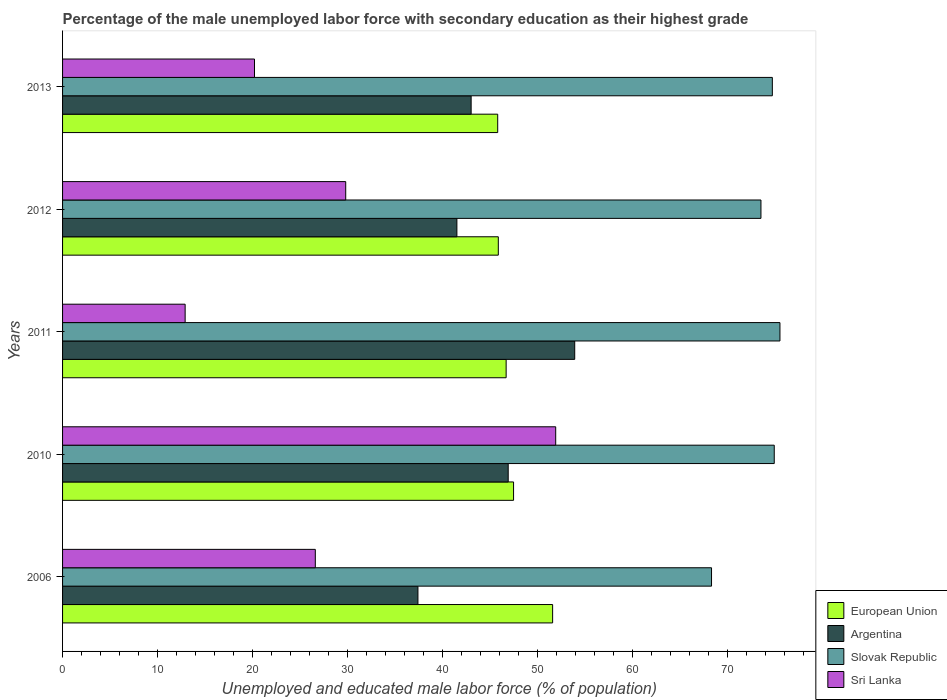How many groups of bars are there?
Your answer should be compact. 5. How many bars are there on the 2nd tick from the top?
Your response must be concise. 4. What is the percentage of the unemployed male labor force with secondary education in Sri Lanka in 2010?
Provide a succinct answer. 51.9. Across all years, what is the maximum percentage of the unemployed male labor force with secondary education in Sri Lanka?
Provide a succinct answer. 51.9. Across all years, what is the minimum percentage of the unemployed male labor force with secondary education in Sri Lanka?
Your answer should be very brief. 12.9. In which year was the percentage of the unemployed male labor force with secondary education in Sri Lanka maximum?
Offer a terse response. 2010. In which year was the percentage of the unemployed male labor force with secondary education in European Union minimum?
Your answer should be compact. 2013. What is the total percentage of the unemployed male labor force with secondary education in Sri Lanka in the graph?
Keep it short and to the point. 141.4. What is the difference between the percentage of the unemployed male labor force with secondary education in Sri Lanka in 2010 and that in 2012?
Provide a short and direct response. 22.1. What is the difference between the percentage of the unemployed male labor force with secondary education in Sri Lanka in 2010 and the percentage of the unemployed male labor force with secondary education in Argentina in 2013?
Your answer should be compact. 8.9. What is the average percentage of the unemployed male labor force with secondary education in Slovak Republic per year?
Make the answer very short. 73.38. In the year 2011, what is the difference between the percentage of the unemployed male labor force with secondary education in Argentina and percentage of the unemployed male labor force with secondary education in Sri Lanka?
Give a very brief answer. 41. What is the ratio of the percentage of the unemployed male labor force with secondary education in Argentina in 2006 to that in 2012?
Your answer should be very brief. 0.9. What is the difference between the highest and the second highest percentage of the unemployed male labor force with secondary education in European Union?
Make the answer very short. 4.11. Is the sum of the percentage of the unemployed male labor force with secondary education in Sri Lanka in 2006 and 2011 greater than the maximum percentage of the unemployed male labor force with secondary education in Slovak Republic across all years?
Provide a short and direct response. No. Is it the case that in every year, the sum of the percentage of the unemployed male labor force with secondary education in European Union and percentage of the unemployed male labor force with secondary education in Sri Lanka is greater than the sum of percentage of the unemployed male labor force with secondary education in Argentina and percentage of the unemployed male labor force with secondary education in Slovak Republic?
Your answer should be very brief. Yes. What does the 4th bar from the top in 2006 represents?
Provide a short and direct response. European Union. What does the 2nd bar from the bottom in 2013 represents?
Make the answer very short. Argentina. Is it the case that in every year, the sum of the percentage of the unemployed male labor force with secondary education in European Union and percentage of the unemployed male labor force with secondary education in Slovak Republic is greater than the percentage of the unemployed male labor force with secondary education in Sri Lanka?
Make the answer very short. Yes. How many bars are there?
Give a very brief answer. 20. Are all the bars in the graph horizontal?
Your answer should be compact. Yes. What is the difference between two consecutive major ticks on the X-axis?
Offer a very short reply. 10. Are the values on the major ticks of X-axis written in scientific E-notation?
Your answer should be compact. No. Does the graph contain any zero values?
Give a very brief answer. No. Where does the legend appear in the graph?
Your response must be concise. Bottom right. How many legend labels are there?
Provide a succinct answer. 4. What is the title of the graph?
Make the answer very short. Percentage of the male unemployed labor force with secondary education as their highest grade. What is the label or title of the X-axis?
Your answer should be compact. Unemployed and educated male labor force (% of population). What is the label or title of the Y-axis?
Make the answer very short. Years. What is the Unemployed and educated male labor force (% of population) in European Union in 2006?
Offer a terse response. 51.58. What is the Unemployed and educated male labor force (% of population) of Argentina in 2006?
Provide a succinct answer. 37.4. What is the Unemployed and educated male labor force (% of population) of Slovak Republic in 2006?
Provide a short and direct response. 68.3. What is the Unemployed and educated male labor force (% of population) of Sri Lanka in 2006?
Give a very brief answer. 26.6. What is the Unemployed and educated male labor force (% of population) in European Union in 2010?
Give a very brief answer. 47.47. What is the Unemployed and educated male labor force (% of population) of Argentina in 2010?
Provide a short and direct response. 46.9. What is the Unemployed and educated male labor force (% of population) in Slovak Republic in 2010?
Give a very brief answer. 74.9. What is the Unemployed and educated male labor force (% of population) in Sri Lanka in 2010?
Give a very brief answer. 51.9. What is the Unemployed and educated male labor force (% of population) of European Union in 2011?
Your answer should be very brief. 46.68. What is the Unemployed and educated male labor force (% of population) of Argentina in 2011?
Provide a short and direct response. 53.9. What is the Unemployed and educated male labor force (% of population) in Slovak Republic in 2011?
Give a very brief answer. 75.5. What is the Unemployed and educated male labor force (% of population) in Sri Lanka in 2011?
Provide a short and direct response. 12.9. What is the Unemployed and educated male labor force (% of population) of European Union in 2012?
Provide a short and direct response. 45.86. What is the Unemployed and educated male labor force (% of population) of Argentina in 2012?
Make the answer very short. 41.5. What is the Unemployed and educated male labor force (% of population) in Slovak Republic in 2012?
Offer a terse response. 73.5. What is the Unemployed and educated male labor force (% of population) of Sri Lanka in 2012?
Ensure brevity in your answer.  29.8. What is the Unemployed and educated male labor force (% of population) in European Union in 2013?
Offer a terse response. 45.79. What is the Unemployed and educated male labor force (% of population) in Slovak Republic in 2013?
Your answer should be compact. 74.7. What is the Unemployed and educated male labor force (% of population) in Sri Lanka in 2013?
Offer a very short reply. 20.2. Across all years, what is the maximum Unemployed and educated male labor force (% of population) in European Union?
Offer a very short reply. 51.58. Across all years, what is the maximum Unemployed and educated male labor force (% of population) in Argentina?
Make the answer very short. 53.9. Across all years, what is the maximum Unemployed and educated male labor force (% of population) of Slovak Republic?
Give a very brief answer. 75.5. Across all years, what is the maximum Unemployed and educated male labor force (% of population) in Sri Lanka?
Give a very brief answer. 51.9. Across all years, what is the minimum Unemployed and educated male labor force (% of population) of European Union?
Offer a very short reply. 45.79. Across all years, what is the minimum Unemployed and educated male labor force (% of population) in Argentina?
Give a very brief answer. 37.4. Across all years, what is the minimum Unemployed and educated male labor force (% of population) in Slovak Republic?
Offer a terse response. 68.3. Across all years, what is the minimum Unemployed and educated male labor force (% of population) of Sri Lanka?
Your answer should be very brief. 12.9. What is the total Unemployed and educated male labor force (% of population) in European Union in the graph?
Keep it short and to the point. 237.38. What is the total Unemployed and educated male labor force (% of population) of Argentina in the graph?
Keep it short and to the point. 222.7. What is the total Unemployed and educated male labor force (% of population) in Slovak Republic in the graph?
Provide a short and direct response. 366.9. What is the total Unemployed and educated male labor force (% of population) in Sri Lanka in the graph?
Keep it short and to the point. 141.4. What is the difference between the Unemployed and educated male labor force (% of population) in European Union in 2006 and that in 2010?
Offer a terse response. 4.11. What is the difference between the Unemployed and educated male labor force (% of population) in Sri Lanka in 2006 and that in 2010?
Your response must be concise. -25.3. What is the difference between the Unemployed and educated male labor force (% of population) in European Union in 2006 and that in 2011?
Provide a succinct answer. 4.89. What is the difference between the Unemployed and educated male labor force (% of population) in Argentina in 2006 and that in 2011?
Offer a very short reply. -16.5. What is the difference between the Unemployed and educated male labor force (% of population) in Slovak Republic in 2006 and that in 2011?
Your response must be concise. -7.2. What is the difference between the Unemployed and educated male labor force (% of population) of European Union in 2006 and that in 2012?
Offer a terse response. 5.72. What is the difference between the Unemployed and educated male labor force (% of population) of Argentina in 2006 and that in 2012?
Offer a very short reply. -4.1. What is the difference between the Unemployed and educated male labor force (% of population) of Slovak Republic in 2006 and that in 2012?
Your answer should be compact. -5.2. What is the difference between the Unemployed and educated male labor force (% of population) of European Union in 2006 and that in 2013?
Your answer should be very brief. 5.78. What is the difference between the Unemployed and educated male labor force (% of population) of European Union in 2010 and that in 2011?
Offer a very short reply. 0.78. What is the difference between the Unemployed and educated male labor force (% of population) of Slovak Republic in 2010 and that in 2011?
Provide a short and direct response. -0.6. What is the difference between the Unemployed and educated male labor force (% of population) of European Union in 2010 and that in 2012?
Offer a very short reply. 1.61. What is the difference between the Unemployed and educated male labor force (% of population) of Argentina in 2010 and that in 2012?
Provide a short and direct response. 5.4. What is the difference between the Unemployed and educated male labor force (% of population) of Slovak Republic in 2010 and that in 2012?
Offer a terse response. 1.4. What is the difference between the Unemployed and educated male labor force (% of population) of Sri Lanka in 2010 and that in 2012?
Provide a short and direct response. 22.1. What is the difference between the Unemployed and educated male labor force (% of population) in European Union in 2010 and that in 2013?
Make the answer very short. 1.67. What is the difference between the Unemployed and educated male labor force (% of population) of Argentina in 2010 and that in 2013?
Make the answer very short. 3.9. What is the difference between the Unemployed and educated male labor force (% of population) of Sri Lanka in 2010 and that in 2013?
Provide a short and direct response. 31.7. What is the difference between the Unemployed and educated male labor force (% of population) in European Union in 2011 and that in 2012?
Your answer should be very brief. 0.82. What is the difference between the Unemployed and educated male labor force (% of population) in Sri Lanka in 2011 and that in 2012?
Your answer should be compact. -16.9. What is the difference between the Unemployed and educated male labor force (% of population) in European Union in 2011 and that in 2013?
Your answer should be compact. 0.89. What is the difference between the Unemployed and educated male labor force (% of population) in Argentina in 2011 and that in 2013?
Give a very brief answer. 10.9. What is the difference between the Unemployed and educated male labor force (% of population) of Sri Lanka in 2011 and that in 2013?
Keep it short and to the point. -7.3. What is the difference between the Unemployed and educated male labor force (% of population) in European Union in 2012 and that in 2013?
Your response must be concise. 0.06. What is the difference between the Unemployed and educated male labor force (% of population) of Slovak Republic in 2012 and that in 2013?
Give a very brief answer. -1.2. What is the difference between the Unemployed and educated male labor force (% of population) in European Union in 2006 and the Unemployed and educated male labor force (% of population) in Argentina in 2010?
Provide a short and direct response. 4.68. What is the difference between the Unemployed and educated male labor force (% of population) in European Union in 2006 and the Unemployed and educated male labor force (% of population) in Slovak Republic in 2010?
Give a very brief answer. -23.32. What is the difference between the Unemployed and educated male labor force (% of population) in European Union in 2006 and the Unemployed and educated male labor force (% of population) in Sri Lanka in 2010?
Ensure brevity in your answer.  -0.32. What is the difference between the Unemployed and educated male labor force (% of population) in Argentina in 2006 and the Unemployed and educated male labor force (% of population) in Slovak Republic in 2010?
Your answer should be very brief. -37.5. What is the difference between the Unemployed and educated male labor force (% of population) in Argentina in 2006 and the Unemployed and educated male labor force (% of population) in Sri Lanka in 2010?
Offer a terse response. -14.5. What is the difference between the Unemployed and educated male labor force (% of population) of Slovak Republic in 2006 and the Unemployed and educated male labor force (% of population) of Sri Lanka in 2010?
Make the answer very short. 16.4. What is the difference between the Unemployed and educated male labor force (% of population) of European Union in 2006 and the Unemployed and educated male labor force (% of population) of Argentina in 2011?
Make the answer very short. -2.32. What is the difference between the Unemployed and educated male labor force (% of population) in European Union in 2006 and the Unemployed and educated male labor force (% of population) in Slovak Republic in 2011?
Provide a short and direct response. -23.92. What is the difference between the Unemployed and educated male labor force (% of population) in European Union in 2006 and the Unemployed and educated male labor force (% of population) in Sri Lanka in 2011?
Ensure brevity in your answer.  38.68. What is the difference between the Unemployed and educated male labor force (% of population) of Argentina in 2006 and the Unemployed and educated male labor force (% of population) of Slovak Republic in 2011?
Your answer should be very brief. -38.1. What is the difference between the Unemployed and educated male labor force (% of population) in Argentina in 2006 and the Unemployed and educated male labor force (% of population) in Sri Lanka in 2011?
Make the answer very short. 24.5. What is the difference between the Unemployed and educated male labor force (% of population) of Slovak Republic in 2006 and the Unemployed and educated male labor force (% of population) of Sri Lanka in 2011?
Offer a terse response. 55.4. What is the difference between the Unemployed and educated male labor force (% of population) of European Union in 2006 and the Unemployed and educated male labor force (% of population) of Argentina in 2012?
Offer a terse response. 10.08. What is the difference between the Unemployed and educated male labor force (% of population) in European Union in 2006 and the Unemployed and educated male labor force (% of population) in Slovak Republic in 2012?
Offer a very short reply. -21.92. What is the difference between the Unemployed and educated male labor force (% of population) of European Union in 2006 and the Unemployed and educated male labor force (% of population) of Sri Lanka in 2012?
Provide a succinct answer. 21.78. What is the difference between the Unemployed and educated male labor force (% of population) in Argentina in 2006 and the Unemployed and educated male labor force (% of population) in Slovak Republic in 2012?
Your answer should be compact. -36.1. What is the difference between the Unemployed and educated male labor force (% of population) in Argentina in 2006 and the Unemployed and educated male labor force (% of population) in Sri Lanka in 2012?
Keep it short and to the point. 7.6. What is the difference between the Unemployed and educated male labor force (% of population) of Slovak Republic in 2006 and the Unemployed and educated male labor force (% of population) of Sri Lanka in 2012?
Your response must be concise. 38.5. What is the difference between the Unemployed and educated male labor force (% of population) in European Union in 2006 and the Unemployed and educated male labor force (% of population) in Argentina in 2013?
Offer a very short reply. 8.58. What is the difference between the Unemployed and educated male labor force (% of population) in European Union in 2006 and the Unemployed and educated male labor force (% of population) in Slovak Republic in 2013?
Provide a short and direct response. -23.12. What is the difference between the Unemployed and educated male labor force (% of population) of European Union in 2006 and the Unemployed and educated male labor force (% of population) of Sri Lanka in 2013?
Give a very brief answer. 31.38. What is the difference between the Unemployed and educated male labor force (% of population) in Argentina in 2006 and the Unemployed and educated male labor force (% of population) in Slovak Republic in 2013?
Ensure brevity in your answer.  -37.3. What is the difference between the Unemployed and educated male labor force (% of population) of Argentina in 2006 and the Unemployed and educated male labor force (% of population) of Sri Lanka in 2013?
Offer a terse response. 17.2. What is the difference between the Unemployed and educated male labor force (% of population) in Slovak Republic in 2006 and the Unemployed and educated male labor force (% of population) in Sri Lanka in 2013?
Offer a terse response. 48.1. What is the difference between the Unemployed and educated male labor force (% of population) in European Union in 2010 and the Unemployed and educated male labor force (% of population) in Argentina in 2011?
Provide a short and direct response. -6.43. What is the difference between the Unemployed and educated male labor force (% of population) in European Union in 2010 and the Unemployed and educated male labor force (% of population) in Slovak Republic in 2011?
Your response must be concise. -28.03. What is the difference between the Unemployed and educated male labor force (% of population) of European Union in 2010 and the Unemployed and educated male labor force (% of population) of Sri Lanka in 2011?
Offer a very short reply. 34.57. What is the difference between the Unemployed and educated male labor force (% of population) in Argentina in 2010 and the Unemployed and educated male labor force (% of population) in Slovak Republic in 2011?
Give a very brief answer. -28.6. What is the difference between the Unemployed and educated male labor force (% of population) of European Union in 2010 and the Unemployed and educated male labor force (% of population) of Argentina in 2012?
Offer a terse response. 5.97. What is the difference between the Unemployed and educated male labor force (% of population) of European Union in 2010 and the Unemployed and educated male labor force (% of population) of Slovak Republic in 2012?
Give a very brief answer. -26.03. What is the difference between the Unemployed and educated male labor force (% of population) in European Union in 2010 and the Unemployed and educated male labor force (% of population) in Sri Lanka in 2012?
Give a very brief answer. 17.67. What is the difference between the Unemployed and educated male labor force (% of population) in Argentina in 2010 and the Unemployed and educated male labor force (% of population) in Slovak Republic in 2012?
Your answer should be compact. -26.6. What is the difference between the Unemployed and educated male labor force (% of population) of Slovak Republic in 2010 and the Unemployed and educated male labor force (% of population) of Sri Lanka in 2012?
Make the answer very short. 45.1. What is the difference between the Unemployed and educated male labor force (% of population) of European Union in 2010 and the Unemployed and educated male labor force (% of population) of Argentina in 2013?
Offer a very short reply. 4.47. What is the difference between the Unemployed and educated male labor force (% of population) of European Union in 2010 and the Unemployed and educated male labor force (% of population) of Slovak Republic in 2013?
Your answer should be very brief. -27.23. What is the difference between the Unemployed and educated male labor force (% of population) in European Union in 2010 and the Unemployed and educated male labor force (% of population) in Sri Lanka in 2013?
Make the answer very short. 27.27. What is the difference between the Unemployed and educated male labor force (% of population) in Argentina in 2010 and the Unemployed and educated male labor force (% of population) in Slovak Republic in 2013?
Provide a succinct answer. -27.8. What is the difference between the Unemployed and educated male labor force (% of population) of Argentina in 2010 and the Unemployed and educated male labor force (% of population) of Sri Lanka in 2013?
Keep it short and to the point. 26.7. What is the difference between the Unemployed and educated male labor force (% of population) of Slovak Republic in 2010 and the Unemployed and educated male labor force (% of population) of Sri Lanka in 2013?
Ensure brevity in your answer.  54.7. What is the difference between the Unemployed and educated male labor force (% of population) of European Union in 2011 and the Unemployed and educated male labor force (% of population) of Argentina in 2012?
Provide a succinct answer. 5.18. What is the difference between the Unemployed and educated male labor force (% of population) of European Union in 2011 and the Unemployed and educated male labor force (% of population) of Slovak Republic in 2012?
Keep it short and to the point. -26.82. What is the difference between the Unemployed and educated male labor force (% of population) of European Union in 2011 and the Unemployed and educated male labor force (% of population) of Sri Lanka in 2012?
Provide a short and direct response. 16.88. What is the difference between the Unemployed and educated male labor force (% of population) of Argentina in 2011 and the Unemployed and educated male labor force (% of population) of Slovak Republic in 2012?
Your response must be concise. -19.6. What is the difference between the Unemployed and educated male labor force (% of population) of Argentina in 2011 and the Unemployed and educated male labor force (% of population) of Sri Lanka in 2012?
Your answer should be compact. 24.1. What is the difference between the Unemployed and educated male labor force (% of population) of Slovak Republic in 2011 and the Unemployed and educated male labor force (% of population) of Sri Lanka in 2012?
Provide a succinct answer. 45.7. What is the difference between the Unemployed and educated male labor force (% of population) of European Union in 2011 and the Unemployed and educated male labor force (% of population) of Argentina in 2013?
Make the answer very short. 3.68. What is the difference between the Unemployed and educated male labor force (% of population) in European Union in 2011 and the Unemployed and educated male labor force (% of population) in Slovak Republic in 2013?
Your answer should be compact. -28.02. What is the difference between the Unemployed and educated male labor force (% of population) of European Union in 2011 and the Unemployed and educated male labor force (% of population) of Sri Lanka in 2013?
Provide a short and direct response. 26.48. What is the difference between the Unemployed and educated male labor force (% of population) in Argentina in 2011 and the Unemployed and educated male labor force (% of population) in Slovak Republic in 2013?
Keep it short and to the point. -20.8. What is the difference between the Unemployed and educated male labor force (% of population) of Argentina in 2011 and the Unemployed and educated male labor force (% of population) of Sri Lanka in 2013?
Give a very brief answer. 33.7. What is the difference between the Unemployed and educated male labor force (% of population) of Slovak Republic in 2011 and the Unemployed and educated male labor force (% of population) of Sri Lanka in 2013?
Your answer should be compact. 55.3. What is the difference between the Unemployed and educated male labor force (% of population) of European Union in 2012 and the Unemployed and educated male labor force (% of population) of Argentina in 2013?
Give a very brief answer. 2.86. What is the difference between the Unemployed and educated male labor force (% of population) in European Union in 2012 and the Unemployed and educated male labor force (% of population) in Slovak Republic in 2013?
Offer a terse response. -28.84. What is the difference between the Unemployed and educated male labor force (% of population) of European Union in 2012 and the Unemployed and educated male labor force (% of population) of Sri Lanka in 2013?
Keep it short and to the point. 25.66. What is the difference between the Unemployed and educated male labor force (% of population) in Argentina in 2012 and the Unemployed and educated male labor force (% of population) in Slovak Republic in 2013?
Offer a very short reply. -33.2. What is the difference between the Unemployed and educated male labor force (% of population) in Argentina in 2012 and the Unemployed and educated male labor force (% of population) in Sri Lanka in 2013?
Your response must be concise. 21.3. What is the difference between the Unemployed and educated male labor force (% of population) of Slovak Republic in 2012 and the Unemployed and educated male labor force (% of population) of Sri Lanka in 2013?
Your response must be concise. 53.3. What is the average Unemployed and educated male labor force (% of population) in European Union per year?
Ensure brevity in your answer.  47.48. What is the average Unemployed and educated male labor force (% of population) in Argentina per year?
Make the answer very short. 44.54. What is the average Unemployed and educated male labor force (% of population) in Slovak Republic per year?
Provide a short and direct response. 73.38. What is the average Unemployed and educated male labor force (% of population) of Sri Lanka per year?
Provide a short and direct response. 28.28. In the year 2006, what is the difference between the Unemployed and educated male labor force (% of population) in European Union and Unemployed and educated male labor force (% of population) in Argentina?
Give a very brief answer. 14.18. In the year 2006, what is the difference between the Unemployed and educated male labor force (% of population) in European Union and Unemployed and educated male labor force (% of population) in Slovak Republic?
Make the answer very short. -16.72. In the year 2006, what is the difference between the Unemployed and educated male labor force (% of population) of European Union and Unemployed and educated male labor force (% of population) of Sri Lanka?
Make the answer very short. 24.98. In the year 2006, what is the difference between the Unemployed and educated male labor force (% of population) in Argentina and Unemployed and educated male labor force (% of population) in Slovak Republic?
Make the answer very short. -30.9. In the year 2006, what is the difference between the Unemployed and educated male labor force (% of population) of Slovak Republic and Unemployed and educated male labor force (% of population) of Sri Lanka?
Keep it short and to the point. 41.7. In the year 2010, what is the difference between the Unemployed and educated male labor force (% of population) of European Union and Unemployed and educated male labor force (% of population) of Argentina?
Provide a succinct answer. 0.57. In the year 2010, what is the difference between the Unemployed and educated male labor force (% of population) of European Union and Unemployed and educated male labor force (% of population) of Slovak Republic?
Your answer should be compact. -27.43. In the year 2010, what is the difference between the Unemployed and educated male labor force (% of population) in European Union and Unemployed and educated male labor force (% of population) in Sri Lanka?
Give a very brief answer. -4.43. In the year 2011, what is the difference between the Unemployed and educated male labor force (% of population) of European Union and Unemployed and educated male labor force (% of population) of Argentina?
Offer a terse response. -7.22. In the year 2011, what is the difference between the Unemployed and educated male labor force (% of population) in European Union and Unemployed and educated male labor force (% of population) in Slovak Republic?
Your answer should be compact. -28.82. In the year 2011, what is the difference between the Unemployed and educated male labor force (% of population) of European Union and Unemployed and educated male labor force (% of population) of Sri Lanka?
Give a very brief answer. 33.78. In the year 2011, what is the difference between the Unemployed and educated male labor force (% of population) in Argentina and Unemployed and educated male labor force (% of population) in Slovak Republic?
Your answer should be compact. -21.6. In the year 2011, what is the difference between the Unemployed and educated male labor force (% of population) of Slovak Republic and Unemployed and educated male labor force (% of population) of Sri Lanka?
Make the answer very short. 62.6. In the year 2012, what is the difference between the Unemployed and educated male labor force (% of population) of European Union and Unemployed and educated male labor force (% of population) of Argentina?
Ensure brevity in your answer.  4.36. In the year 2012, what is the difference between the Unemployed and educated male labor force (% of population) of European Union and Unemployed and educated male labor force (% of population) of Slovak Republic?
Your response must be concise. -27.64. In the year 2012, what is the difference between the Unemployed and educated male labor force (% of population) in European Union and Unemployed and educated male labor force (% of population) in Sri Lanka?
Provide a succinct answer. 16.06. In the year 2012, what is the difference between the Unemployed and educated male labor force (% of population) in Argentina and Unemployed and educated male labor force (% of population) in Slovak Republic?
Keep it short and to the point. -32. In the year 2012, what is the difference between the Unemployed and educated male labor force (% of population) in Argentina and Unemployed and educated male labor force (% of population) in Sri Lanka?
Offer a very short reply. 11.7. In the year 2012, what is the difference between the Unemployed and educated male labor force (% of population) in Slovak Republic and Unemployed and educated male labor force (% of population) in Sri Lanka?
Offer a very short reply. 43.7. In the year 2013, what is the difference between the Unemployed and educated male labor force (% of population) of European Union and Unemployed and educated male labor force (% of population) of Argentina?
Give a very brief answer. 2.79. In the year 2013, what is the difference between the Unemployed and educated male labor force (% of population) of European Union and Unemployed and educated male labor force (% of population) of Slovak Republic?
Your answer should be very brief. -28.91. In the year 2013, what is the difference between the Unemployed and educated male labor force (% of population) of European Union and Unemployed and educated male labor force (% of population) of Sri Lanka?
Your response must be concise. 25.59. In the year 2013, what is the difference between the Unemployed and educated male labor force (% of population) in Argentina and Unemployed and educated male labor force (% of population) in Slovak Republic?
Ensure brevity in your answer.  -31.7. In the year 2013, what is the difference between the Unemployed and educated male labor force (% of population) of Argentina and Unemployed and educated male labor force (% of population) of Sri Lanka?
Offer a terse response. 22.8. In the year 2013, what is the difference between the Unemployed and educated male labor force (% of population) in Slovak Republic and Unemployed and educated male labor force (% of population) in Sri Lanka?
Offer a terse response. 54.5. What is the ratio of the Unemployed and educated male labor force (% of population) of European Union in 2006 to that in 2010?
Your response must be concise. 1.09. What is the ratio of the Unemployed and educated male labor force (% of population) of Argentina in 2006 to that in 2010?
Provide a short and direct response. 0.8. What is the ratio of the Unemployed and educated male labor force (% of population) of Slovak Republic in 2006 to that in 2010?
Make the answer very short. 0.91. What is the ratio of the Unemployed and educated male labor force (% of population) in Sri Lanka in 2006 to that in 2010?
Provide a succinct answer. 0.51. What is the ratio of the Unemployed and educated male labor force (% of population) of European Union in 2006 to that in 2011?
Make the answer very short. 1.1. What is the ratio of the Unemployed and educated male labor force (% of population) of Argentina in 2006 to that in 2011?
Your answer should be very brief. 0.69. What is the ratio of the Unemployed and educated male labor force (% of population) in Slovak Republic in 2006 to that in 2011?
Offer a terse response. 0.9. What is the ratio of the Unemployed and educated male labor force (% of population) of Sri Lanka in 2006 to that in 2011?
Ensure brevity in your answer.  2.06. What is the ratio of the Unemployed and educated male labor force (% of population) in European Union in 2006 to that in 2012?
Provide a short and direct response. 1.12. What is the ratio of the Unemployed and educated male labor force (% of population) in Argentina in 2006 to that in 2012?
Your answer should be compact. 0.9. What is the ratio of the Unemployed and educated male labor force (% of population) of Slovak Republic in 2006 to that in 2012?
Make the answer very short. 0.93. What is the ratio of the Unemployed and educated male labor force (% of population) in Sri Lanka in 2006 to that in 2012?
Make the answer very short. 0.89. What is the ratio of the Unemployed and educated male labor force (% of population) in European Union in 2006 to that in 2013?
Your response must be concise. 1.13. What is the ratio of the Unemployed and educated male labor force (% of population) in Argentina in 2006 to that in 2013?
Provide a short and direct response. 0.87. What is the ratio of the Unemployed and educated male labor force (% of population) of Slovak Republic in 2006 to that in 2013?
Make the answer very short. 0.91. What is the ratio of the Unemployed and educated male labor force (% of population) in Sri Lanka in 2006 to that in 2013?
Keep it short and to the point. 1.32. What is the ratio of the Unemployed and educated male labor force (% of population) in European Union in 2010 to that in 2011?
Provide a succinct answer. 1.02. What is the ratio of the Unemployed and educated male labor force (% of population) in Argentina in 2010 to that in 2011?
Offer a terse response. 0.87. What is the ratio of the Unemployed and educated male labor force (% of population) of Sri Lanka in 2010 to that in 2011?
Provide a short and direct response. 4.02. What is the ratio of the Unemployed and educated male labor force (% of population) of European Union in 2010 to that in 2012?
Keep it short and to the point. 1.03. What is the ratio of the Unemployed and educated male labor force (% of population) in Argentina in 2010 to that in 2012?
Ensure brevity in your answer.  1.13. What is the ratio of the Unemployed and educated male labor force (% of population) of Sri Lanka in 2010 to that in 2012?
Provide a short and direct response. 1.74. What is the ratio of the Unemployed and educated male labor force (% of population) of European Union in 2010 to that in 2013?
Your answer should be very brief. 1.04. What is the ratio of the Unemployed and educated male labor force (% of population) of Argentina in 2010 to that in 2013?
Give a very brief answer. 1.09. What is the ratio of the Unemployed and educated male labor force (% of population) of Slovak Republic in 2010 to that in 2013?
Provide a short and direct response. 1. What is the ratio of the Unemployed and educated male labor force (% of population) in Sri Lanka in 2010 to that in 2013?
Your answer should be compact. 2.57. What is the ratio of the Unemployed and educated male labor force (% of population) in European Union in 2011 to that in 2012?
Your answer should be very brief. 1.02. What is the ratio of the Unemployed and educated male labor force (% of population) of Argentina in 2011 to that in 2012?
Give a very brief answer. 1.3. What is the ratio of the Unemployed and educated male labor force (% of population) in Slovak Republic in 2011 to that in 2012?
Give a very brief answer. 1.03. What is the ratio of the Unemployed and educated male labor force (% of population) of Sri Lanka in 2011 to that in 2012?
Your answer should be very brief. 0.43. What is the ratio of the Unemployed and educated male labor force (% of population) of European Union in 2011 to that in 2013?
Make the answer very short. 1.02. What is the ratio of the Unemployed and educated male labor force (% of population) in Argentina in 2011 to that in 2013?
Your answer should be very brief. 1.25. What is the ratio of the Unemployed and educated male labor force (% of population) in Slovak Republic in 2011 to that in 2013?
Your answer should be compact. 1.01. What is the ratio of the Unemployed and educated male labor force (% of population) in Sri Lanka in 2011 to that in 2013?
Make the answer very short. 0.64. What is the ratio of the Unemployed and educated male labor force (% of population) of Argentina in 2012 to that in 2013?
Your answer should be compact. 0.97. What is the ratio of the Unemployed and educated male labor force (% of population) of Slovak Republic in 2012 to that in 2013?
Your response must be concise. 0.98. What is the ratio of the Unemployed and educated male labor force (% of population) of Sri Lanka in 2012 to that in 2013?
Keep it short and to the point. 1.48. What is the difference between the highest and the second highest Unemployed and educated male labor force (% of population) in European Union?
Ensure brevity in your answer.  4.11. What is the difference between the highest and the second highest Unemployed and educated male labor force (% of population) in Sri Lanka?
Offer a terse response. 22.1. What is the difference between the highest and the lowest Unemployed and educated male labor force (% of population) in European Union?
Offer a terse response. 5.78. What is the difference between the highest and the lowest Unemployed and educated male labor force (% of population) in Argentina?
Your answer should be very brief. 16.5. 